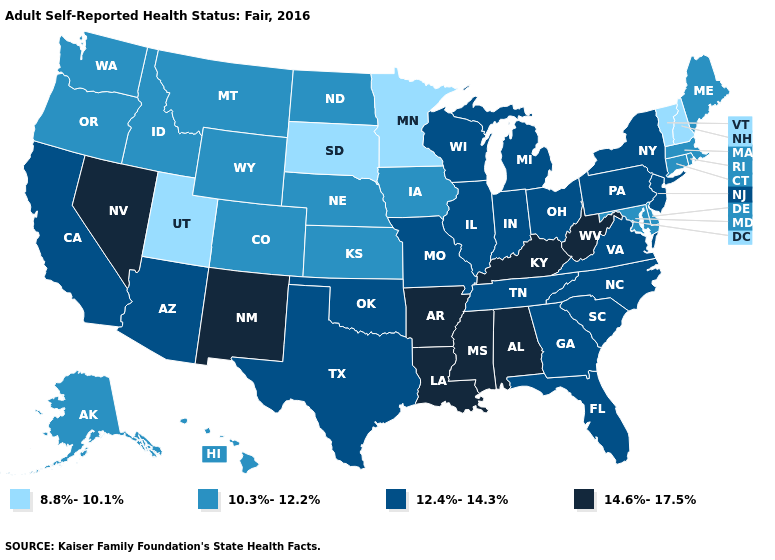Name the states that have a value in the range 10.3%-12.2%?
Concise answer only. Alaska, Colorado, Connecticut, Delaware, Hawaii, Idaho, Iowa, Kansas, Maine, Maryland, Massachusetts, Montana, Nebraska, North Dakota, Oregon, Rhode Island, Washington, Wyoming. Does the map have missing data?
Quick response, please. No. What is the highest value in states that border Illinois?
Be succinct. 14.6%-17.5%. Among the states that border North Dakota , which have the lowest value?
Write a very short answer. Minnesota, South Dakota. Name the states that have a value in the range 12.4%-14.3%?
Quick response, please. Arizona, California, Florida, Georgia, Illinois, Indiana, Michigan, Missouri, New Jersey, New York, North Carolina, Ohio, Oklahoma, Pennsylvania, South Carolina, Tennessee, Texas, Virginia, Wisconsin. Which states have the lowest value in the MidWest?
Concise answer only. Minnesota, South Dakota. What is the value of Rhode Island?
Give a very brief answer. 10.3%-12.2%. Name the states that have a value in the range 14.6%-17.5%?
Concise answer only. Alabama, Arkansas, Kentucky, Louisiana, Mississippi, Nevada, New Mexico, West Virginia. Name the states that have a value in the range 14.6%-17.5%?
Keep it brief. Alabama, Arkansas, Kentucky, Louisiana, Mississippi, Nevada, New Mexico, West Virginia. Does the first symbol in the legend represent the smallest category?
Short answer required. Yes. How many symbols are there in the legend?
Keep it brief. 4. Is the legend a continuous bar?
Write a very short answer. No. Among the states that border Georgia , does South Carolina have the highest value?
Keep it brief. No. What is the value of Florida?
Keep it brief. 12.4%-14.3%. 